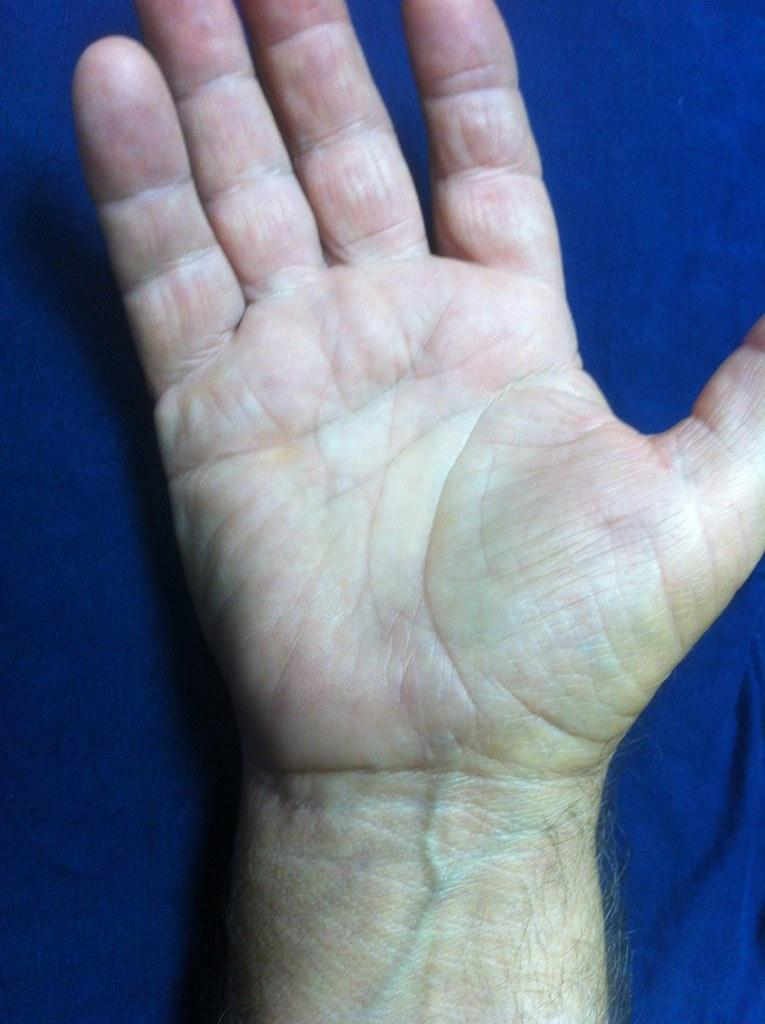What is the main subject of the image? The main subject of the image is a hand. To whom does the hand belong? The hand belongs to a person. What color is the surface the hand is on? The hand is on a blue surface. What type of ink is being used by the hand in the image? There is no ink present in the image; it only features a hand on a blue surface. 